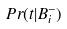Convert formula to latex. <formula><loc_0><loc_0><loc_500><loc_500>P r ( t | B _ { i } ^ { - } )</formula> 